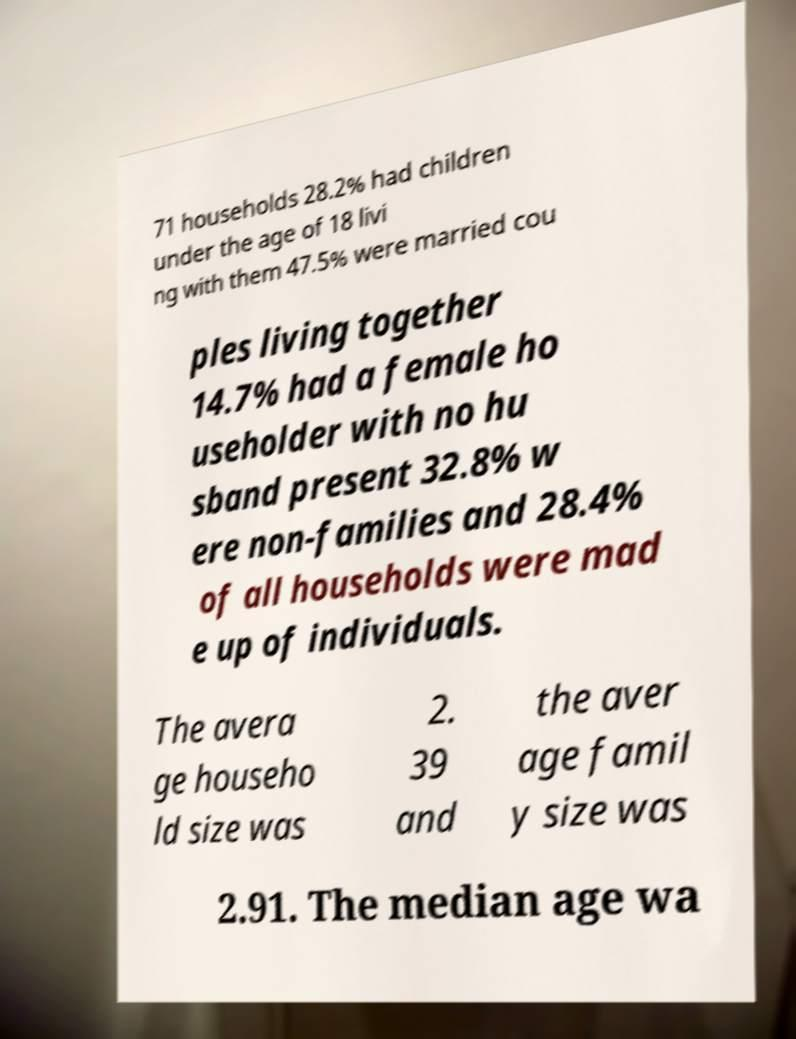What messages or text are displayed in this image? I need them in a readable, typed format. 71 households 28.2% had children under the age of 18 livi ng with them 47.5% were married cou ples living together 14.7% had a female ho useholder with no hu sband present 32.8% w ere non-families and 28.4% of all households were mad e up of individuals. The avera ge househo ld size was 2. 39 and the aver age famil y size was 2.91. The median age wa 